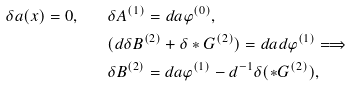Convert formula to latex. <formula><loc_0><loc_0><loc_500><loc_500>\delta a ( x ) = 0 , \quad & \delta { A } ^ { ( 1 ) } = d a { \varphi } ^ { ( 0 ) } , \\ & ( d \delta { B } ^ { ( 2 ) } + \delta \ast { G } ^ { ( 2 ) } ) = d a d { \varphi } ^ { ( 1 ) } \Longrightarrow \\ & \delta { B } ^ { ( 2 ) } = d a { \varphi } ^ { ( 1 ) } - d ^ { - 1 } \delta ( \ast { G } ^ { ( 2 ) } ) ,</formula> 